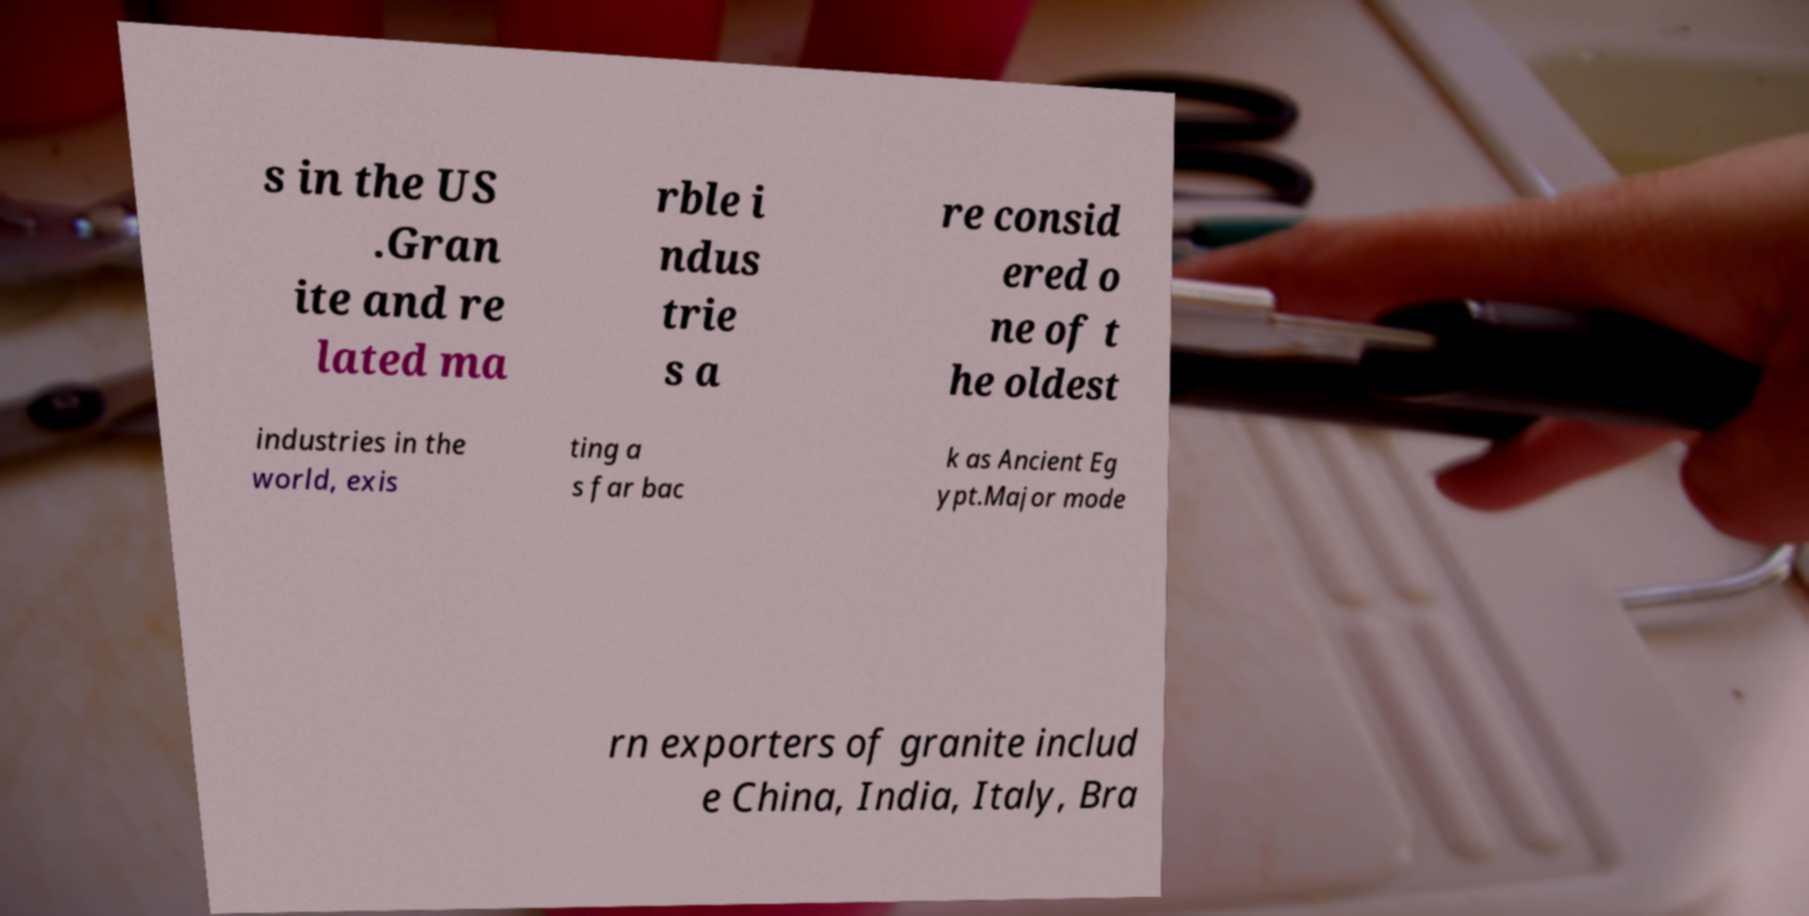Can you accurately transcribe the text from the provided image for me? s in the US .Gran ite and re lated ma rble i ndus trie s a re consid ered o ne of t he oldest industries in the world, exis ting a s far bac k as Ancient Eg ypt.Major mode rn exporters of granite includ e China, India, Italy, Bra 